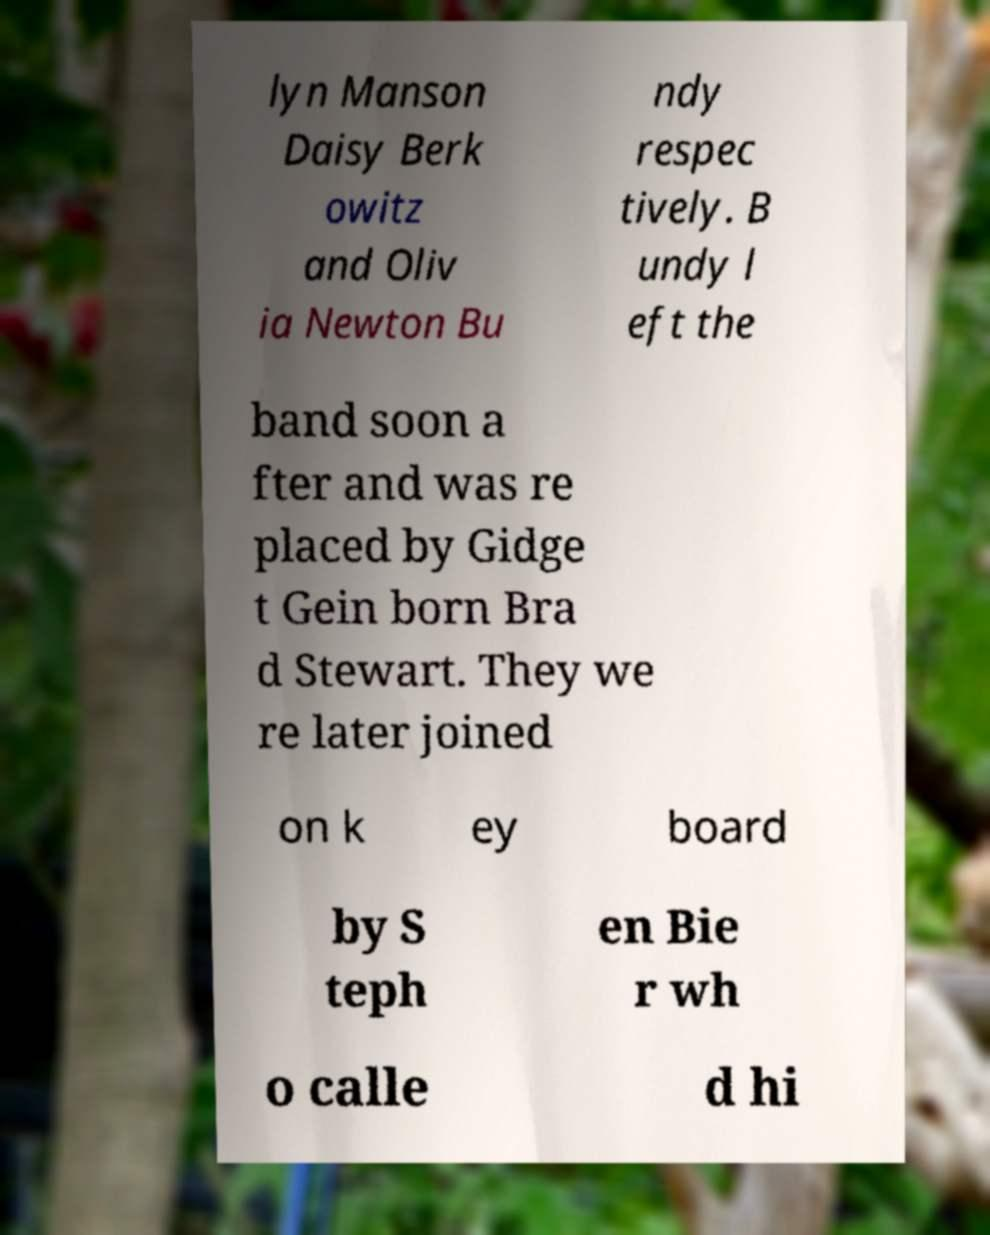I need the written content from this picture converted into text. Can you do that? lyn Manson Daisy Berk owitz and Oliv ia Newton Bu ndy respec tively. B undy l eft the band soon a fter and was re placed by Gidge t Gein born Bra d Stewart. They we re later joined on k ey board by S teph en Bie r wh o calle d hi 